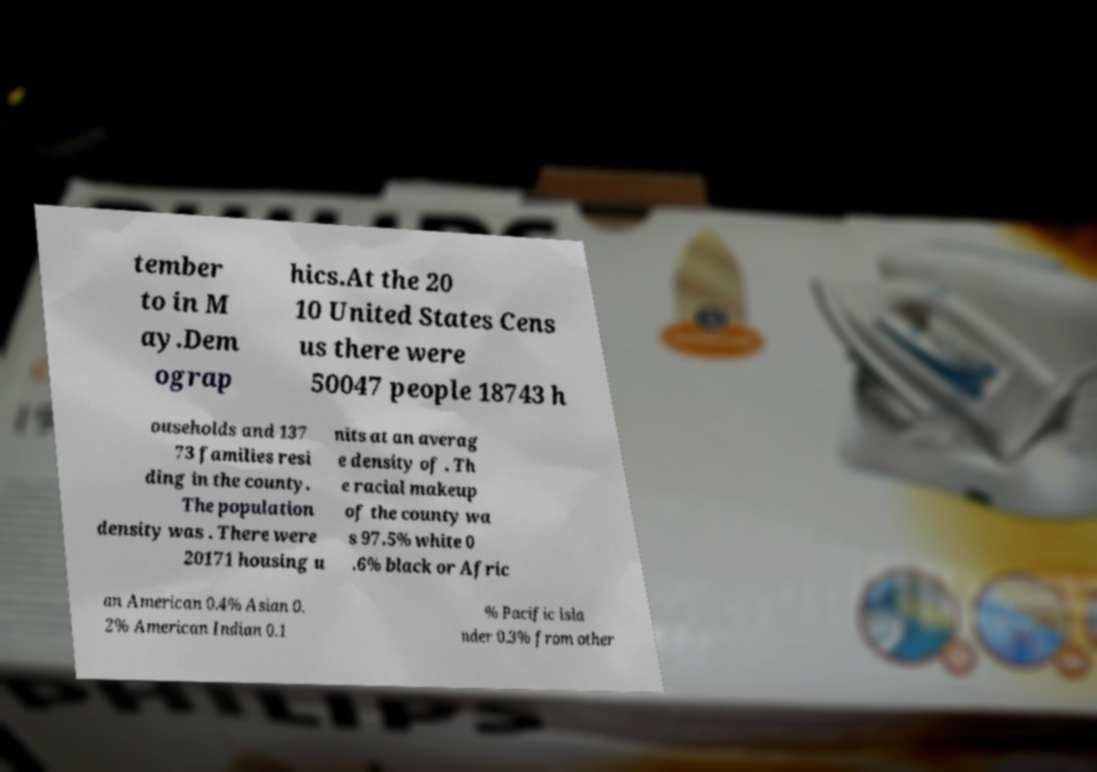Could you extract and type out the text from this image? tember to in M ay.Dem ograp hics.At the 20 10 United States Cens us there were 50047 people 18743 h ouseholds and 137 73 families resi ding in the county. The population density was . There were 20171 housing u nits at an averag e density of . Th e racial makeup of the county wa s 97.5% white 0 .6% black or Afric an American 0.4% Asian 0. 2% American Indian 0.1 % Pacific isla nder 0.3% from other 